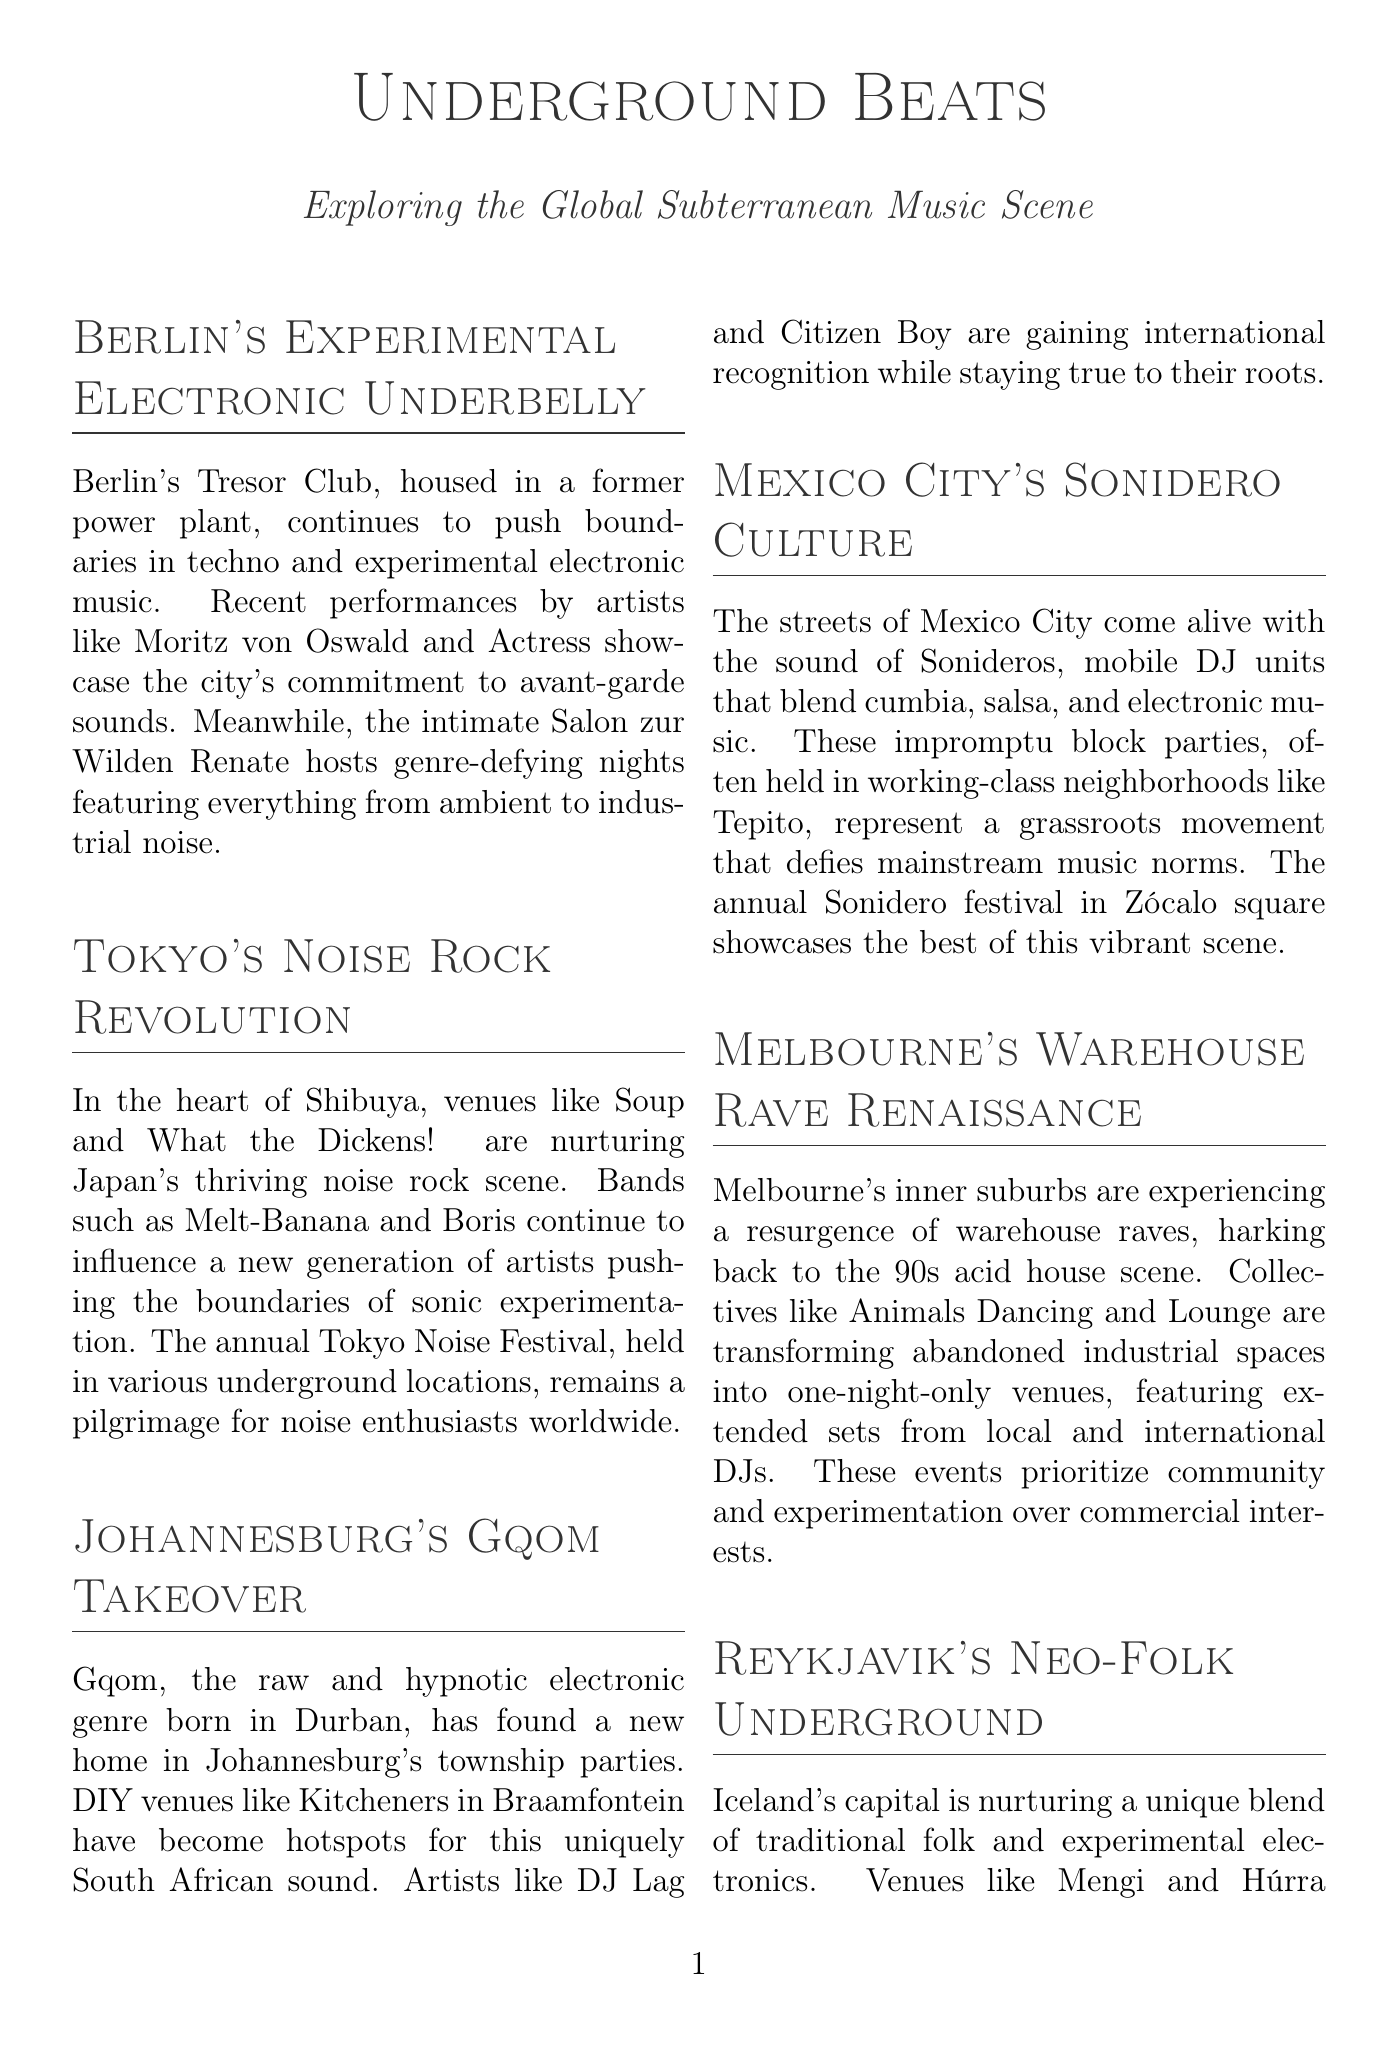What is the venue in Berlin known for experimental electronic music? The document mentions Tresor Club as a key venue in Berlin for experimental electronic music.
Answer: Tresor Club Who is a featured artist from Japan? Melt-Banana is identified as a featured artist from Japan known for noise rock.
Answer: Melt-Banana What genre does DJ Lag represent? The document specifically states DJ Lag is a pioneering producer of the Gqom genre.
Answer: Gqom Which festival in Tokyo aids noise enthusiasts? The annual Tokyo Noise Festival is highlighted as a key event for noise enthusiasts in the document.
Answer: Tokyo Noise Festival What is the location of the venue Mengi? Mengi is identified in the document as being located in Reykjavik, Iceland.
Answer: Reykjavik, Iceland Which two artists are mentioned in connection with Johannesburg's Gqom scene? The document references DJ Lag and Citizen Boy as key artists in Johannesburg's Gqom scene.
Answer: DJ Lag and Citizen Boy What type of events do collectives like Animals Dancing in Melbourne focus on? The document indicates that these collectives prioritize community and experimentation over commercial interests in their events.
Answer: Community and experimentation What is the style of music associated with Ólöf Arnalds? The document describes Ólöf Arnalds' music as a blend of traditional folk with experimental electronic elements.
Answer: Traditional folk and experimental electronic What describes the venue Soup in Tokyo? Soup is characterized in the document as a tiny basement venue renowned for hosting cutting-edge noise and experimental acts.
Answer: Tiny basement venue 